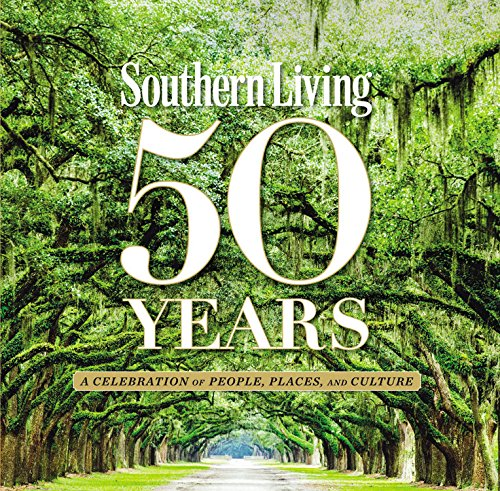What is the significance of the image on the cover? The cover features a lush Southern landscape, likely a live oak avenue, which symbolizes the deep-rooted traditions and natural beauty of the South. This iconic imagery sets the tone for the book, inviting readers to explore the rich cultural and natural heritage celebrated within its pages. 